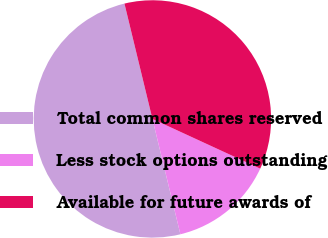Convert chart to OTSL. <chart><loc_0><loc_0><loc_500><loc_500><pie_chart><fcel>Total common shares reserved<fcel>Less stock options outstanding<fcel>Available for future awards of<nl><fcel>50.0%<fcel>14.34%<fcel>35.66%<nl></chart> 